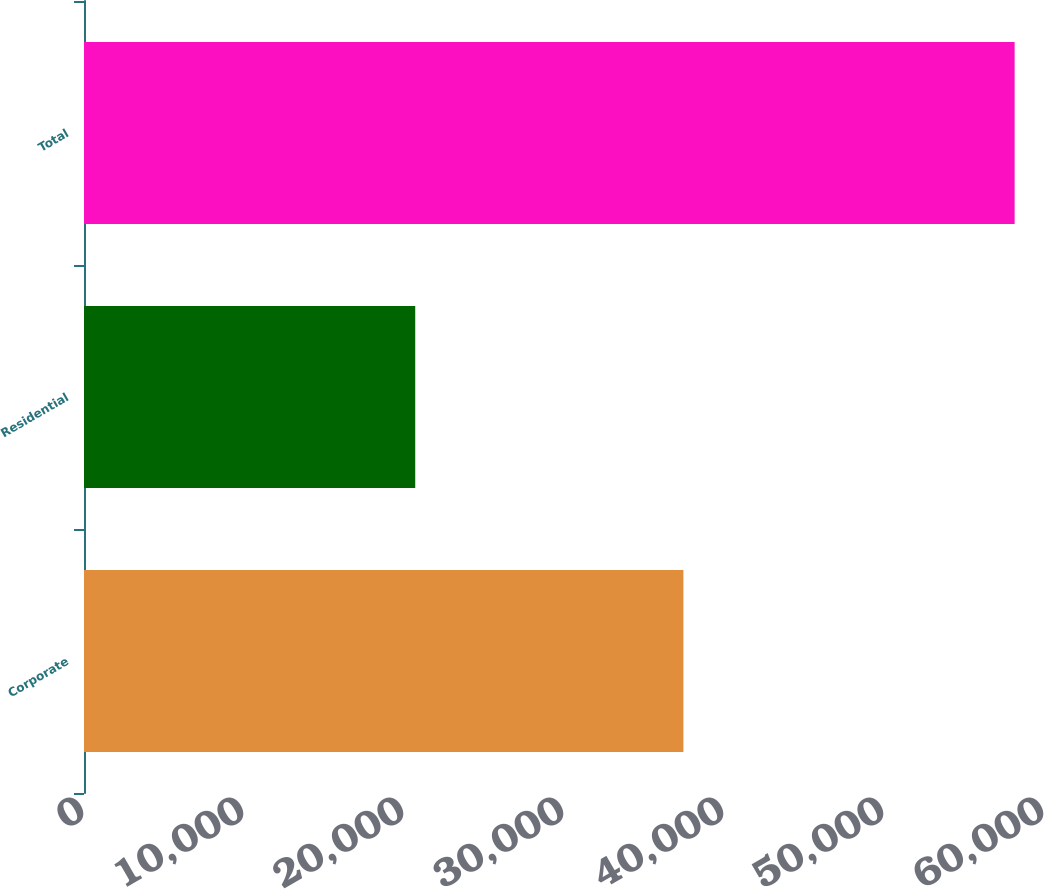Convert chart to OTSL. <chart><loc_0><loc_0><loc_500><loc_500><bar_chart><fcel>Corporate<fcel>Residential<fcel>Total<nl><fcel>37462<fcel>20702<fcel>58164<nl></chart> 